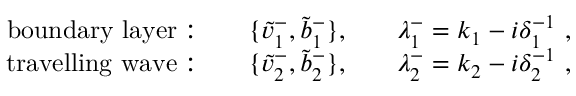Convert formula to latex. <formula><loc_0><loc_0><loc_500><loc_500>\begin{array} { r l r l r } { b o u n d a r y l a y e r \colon } & { \{ \tilde { v } _ { 1 } ^ { - } , \tilde { b } _ { 1 } ^ { - } \} , } & { \lambda _ { 1 } ^ { - } = k _ { 1 } - i \delta _ { 1 } ^ { - 1 } , } \\ { t r a v e l l i n g w a v e \colon } & { \{ \tilde { v } _ { 2 } ^ { - } , \tilde { b } _ { 2 } ^ { - } \} , } & { \lambda _ { 2 } ^ { - } = k _ { 2 } - i \delta _ { 2 } ^ { - 1 } , } \end{array}</formula> 